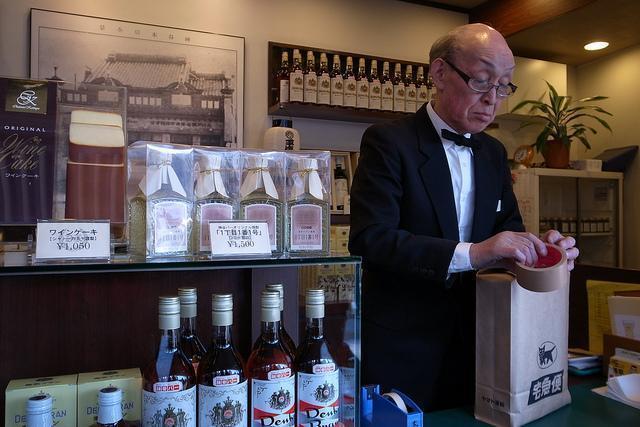What sort of beverages are sold here?
Pick the correct solution from the four options below to address the question.
Options: Milk, sodas, mixers, alcoholic. Alcoholic. 